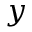Convert formula to latex. <formula><loc_0><loc_0><loc_500><loc_500>y</formula> 